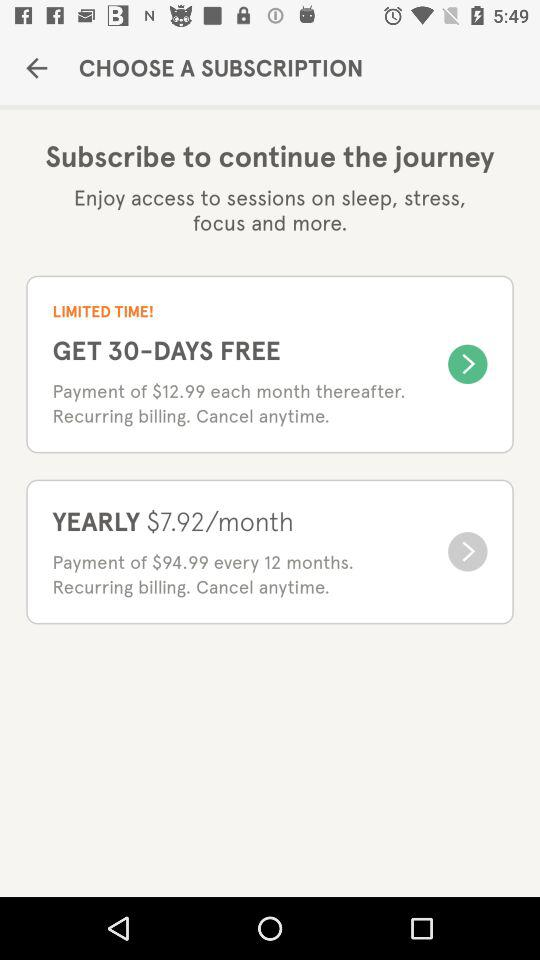How much is the monthly subscription after the initial 30 days?
Answer the question using a single word or phrase. $12.99 